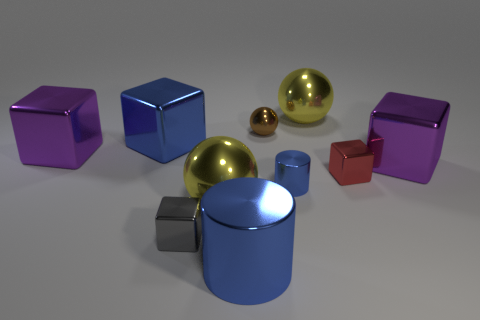How many blue cylinders must be subtracted to get 1 blue cylinders? 1 Subtract all small metal balls. How many balls are left? 2 Subtract all purple cubes. How many cubes are left? 3 Subtract all balls. How many objects are left? 7 Subtract all brown cylinders. Subtract all cyan balls. How many cylinders are left? 2 Subtract all brown cubes. How many yellow cylinders are left? 0 Subtract all gray metal blocks. Subtract all small brown matte cylinders. How many objects are left? 9 Add 7 small red things. How many small red things are left? 8 Add 3 gray metal cubes. How many gray metal cubes exist? 4 Subtract 0 green cylinders. How many objects are left? 10 